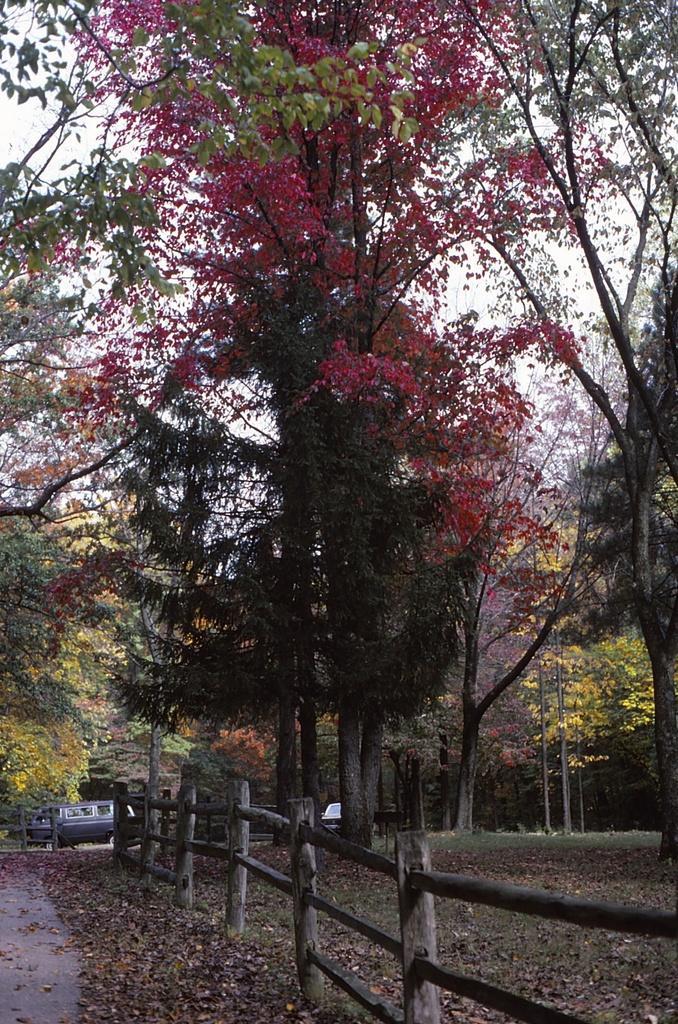Please provide a concise description of this image. In front of the image there is a wooden fence. At the bottom of the image there are dried leaves. There are vehicles on the road. In the background of the image there are trees and sky. 